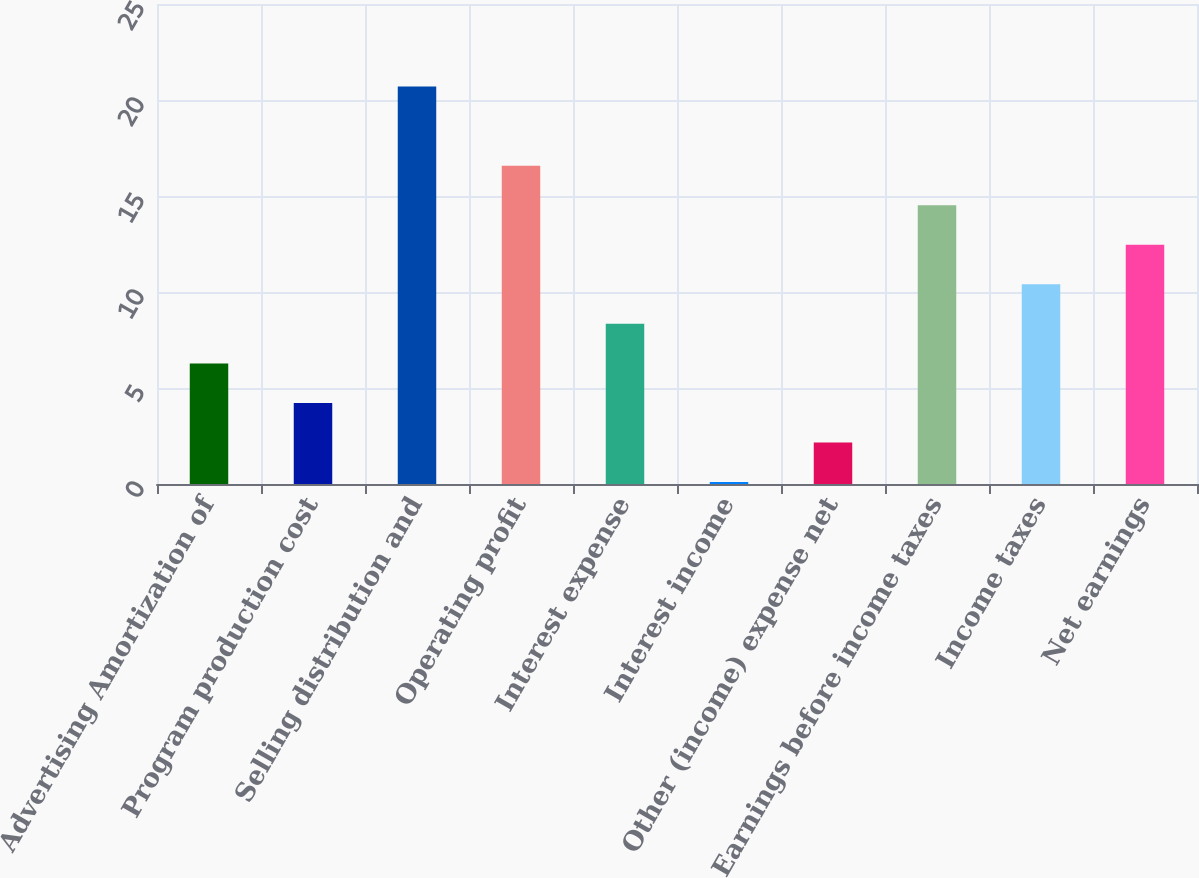<chart> <loc_0><loc_0><loc_500><loc_500><bar_chart><fcel>Advertising Amortization of<fcel>Program production cost<fcel>Selling distribution and<fcel>Operating profit<fcel>Interest expense<fcel>Interest income<fcel>Other (income) expense net<fcel>Earnings before income taxes<fcel>Income taxes<fcel>Net earnings<nl><fcel>6.28<fcel>4.22<fcel>20.7<fcel>16.58<fcel>8.34<fcel>0.1<fcel>2.16<fcel>14.52<fcel>10.4<fcel>12.46<nl></chart> 